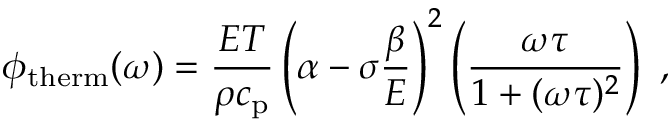Convert formula to latex. <formula><loc_0><loc_0><loc_500><loc_500>\phi _ { t h e r m } ( \omega ) = \frac { E T } { \rho c _ { p } } \left ( \alpha - \sigma \frac { \beta } { E } \right ) ^ { 2 } \left ( \frac { \omega \tau } { 1 + ( \omega \tau ) ^ { 2 } } \right ) ,</formula> 